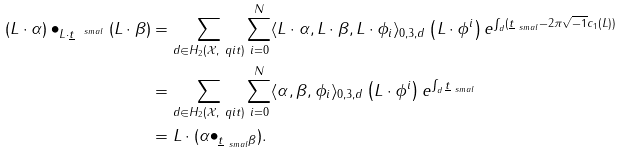<formula> <loc_0><loc_0><loc_500><loc_500>( L \cdot \alpha ) \bullet _ { L \cdot \underline { t } ^ { \ s m a l } } ( L \cdot \beta ) & = \sum _ { d \in H _ { 2 } ( \mathcal { X } , \ q i t ) } \sum _ { i = 0 } ^ { N } \langle L \cdot \alpha , L \cdot \beta , L \cdot \phi _ { i } \rangle _ { 0 , 3 , d } \left ( L \cdot \phi ^ { i } \right ) e ^ { \int _ { d } ( \underline { t } _ { \ s m a l } - 2 \pi \sqrt { - 1 } c _ { 1 } ( L ) ) } \\ & = \sum _ { d \in H _ { 2 } ( \mathcal { X } , \ q i t ) } \sum _ { i = 0 } ^ { N } \langle \alpha , \beta , \phi _ { i } \rangle _ { 0 , 3 , d } \left ( L \cdot \phi ^ { i } \right ) e ^ { \int _ { d } \underline { t } _ { \ s m a l } } \\ & = L \cdot ( \alpha \bullet _ { \underline { t } _ { \ s m a l } \beta } ) .</formula> 